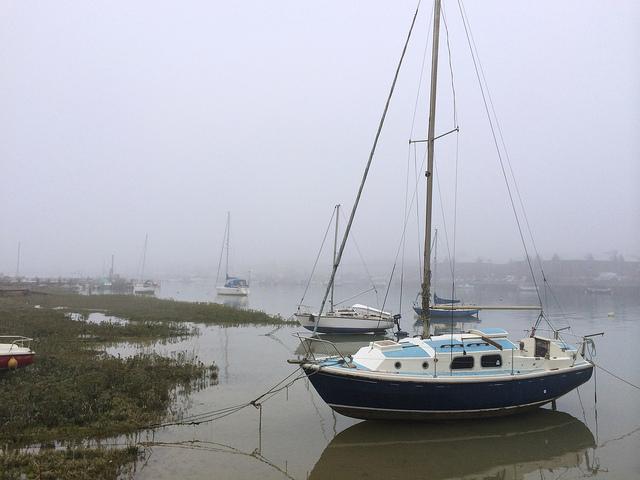Is this a boat dock?
Write a very short answer. No. Is it foggy?
Short answer required. Yes. How many ship masts are there?
Keep it brief. 6. Is there mountains?
Write a very short answer. No. What type of weather condition is in the harbor?
Give a very brief answer. Foggy. What color is the sky?
Short answer required. Gray. What color is the water?
Keep it brief. Gray. 